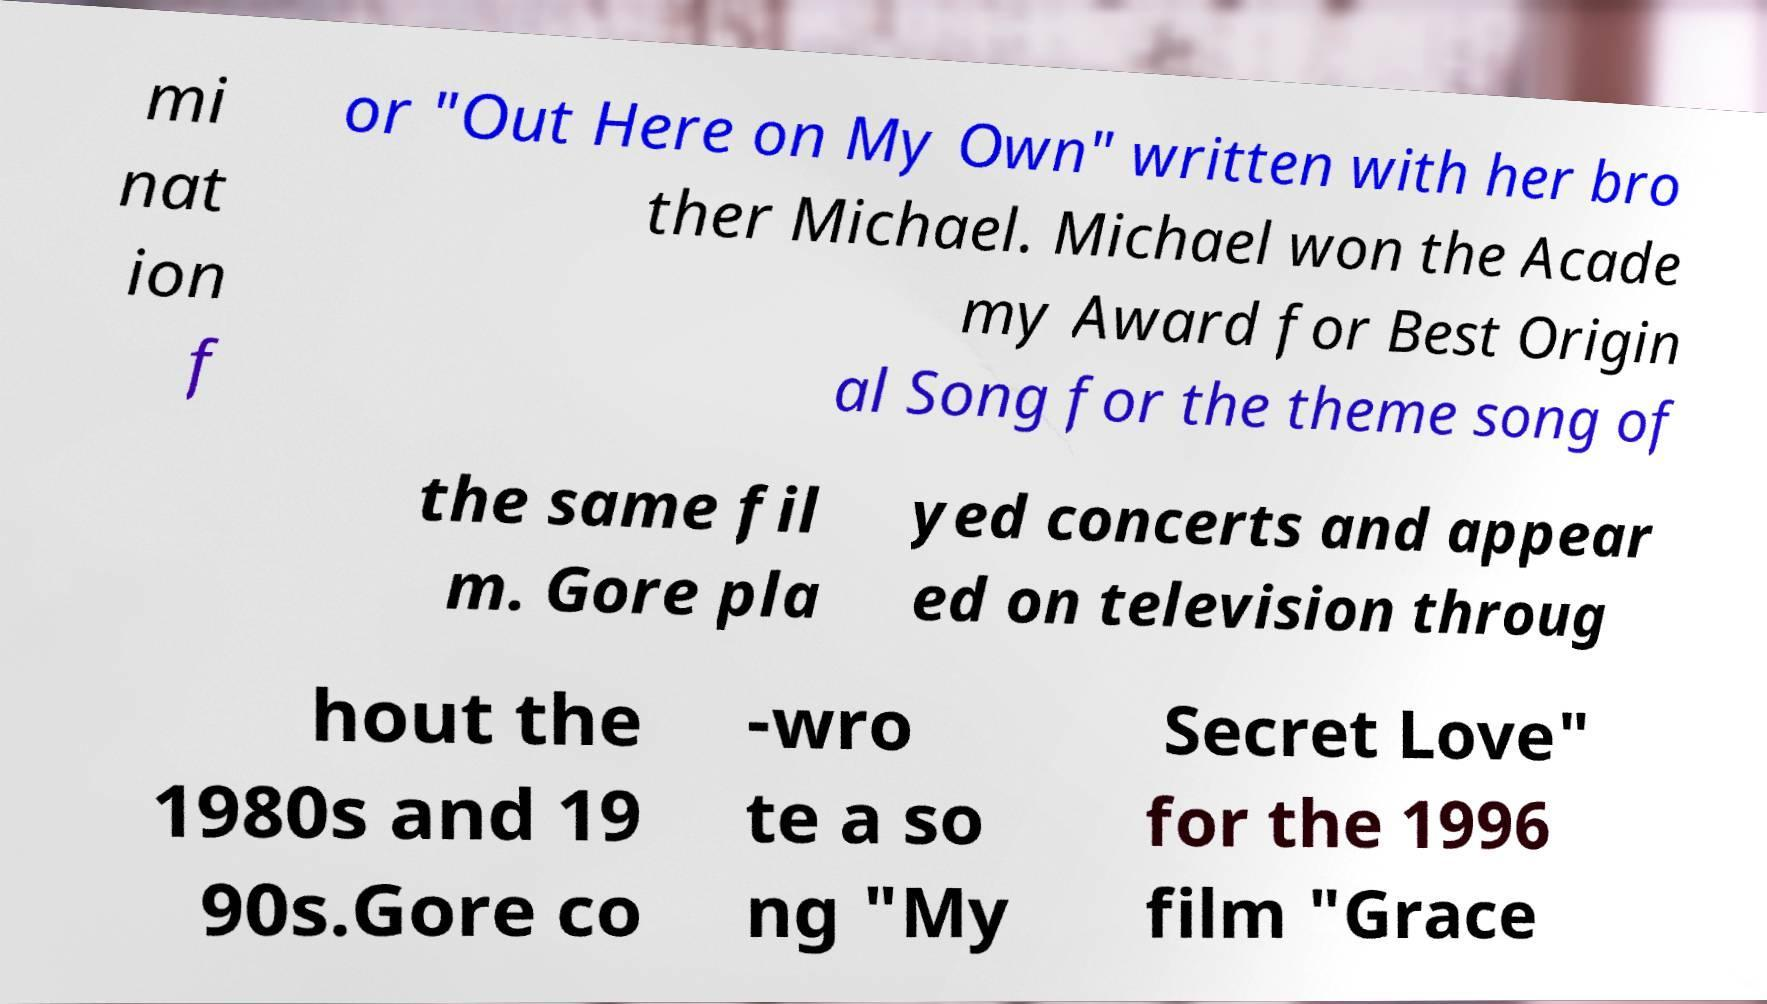What messages or text are displayed in this image? I need them in a readable, typed format. mi nat ion f or "Out Here on My Own" written with her bro ther Michael. Michael won the Acade my Award for Best Origin al Song for the theme song of the same fil m. Gore pla yed concerts and appear ed on television throug hout the 1980s and 19 90s.Gore co -wro te a so ng "My Secret Love" for the 1996 film "Grace 